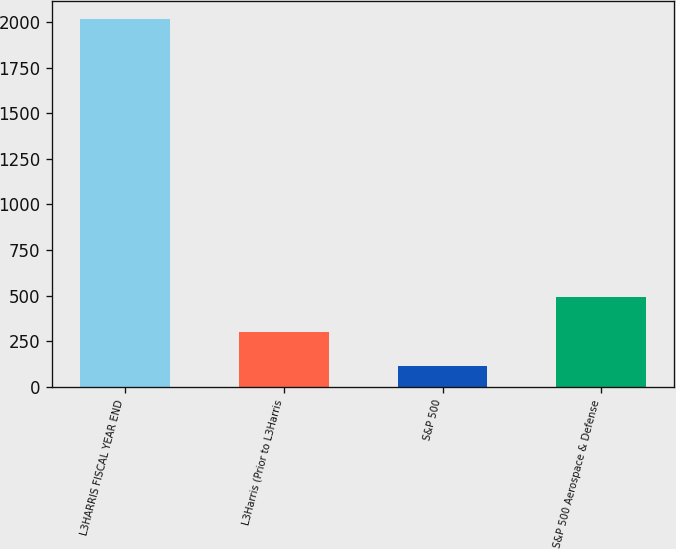Convert chart to OTSL. <chart><loc_0><loc_0><loc_500><loc_500><bar_chart><fcel>L3HARRIS FISCAL YEAR END<fcel>L3Harris (Prior to L3Harris<fcel>S&P 500<fcel>S&P 500 Aerospace & Defense<nl><fcel>2016<fcel>302.4<fcel>112<fcel>492.8<nl></chart> 